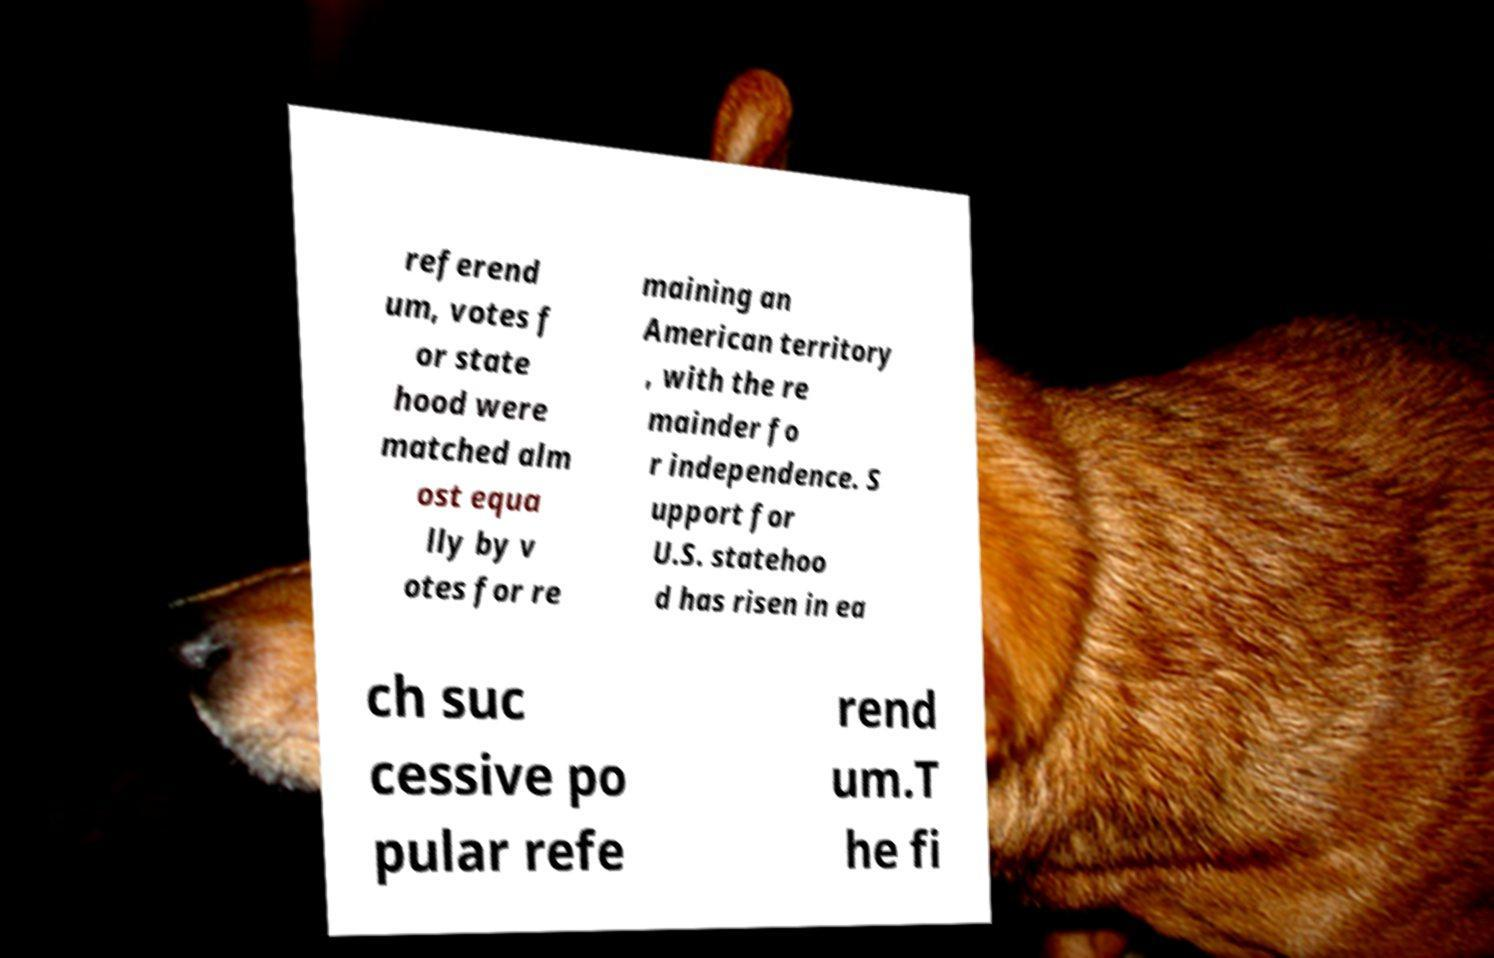For documentation purposes, I need the text within this image transcribed. Could you provide that? referend um, votes f or state hood were matched alm ost equa lly by v otes for re maining an American territory , with the re mainder fo r independence. S upport for U.S. statehoo d has risen in ea ch suc cessive po pular refe rend um.T he fi 